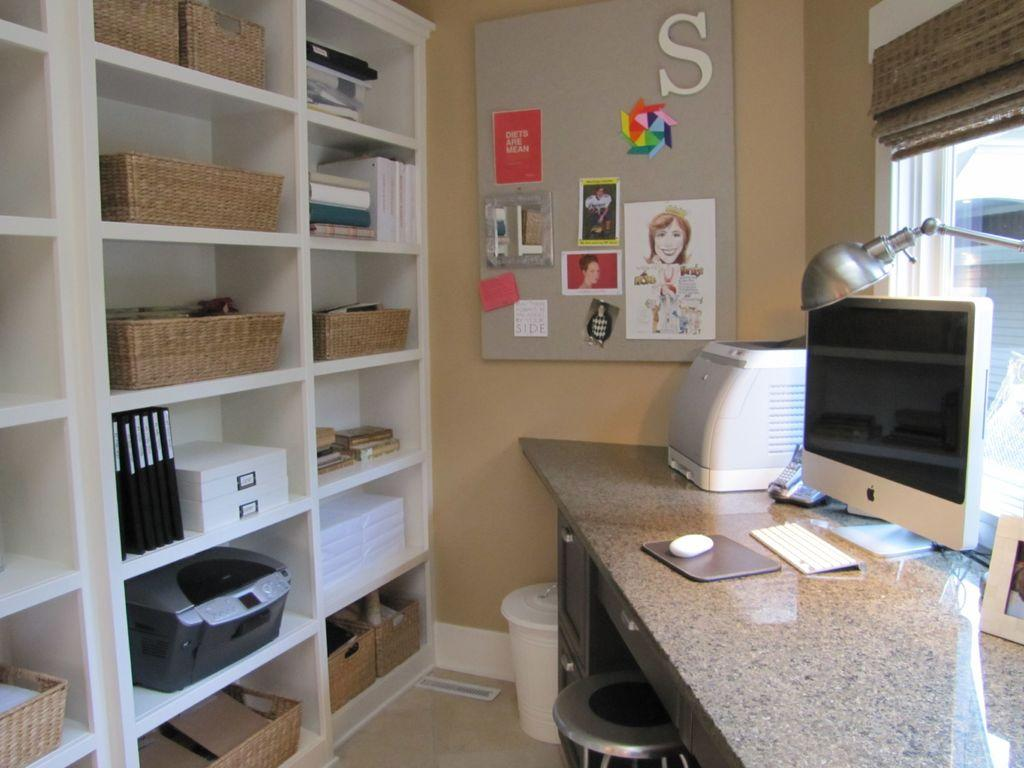Provide a one-sentence caption for the provided image. A home office with a corner desk by a window and a bulletin board on the wall that has a large letter S near the top. 